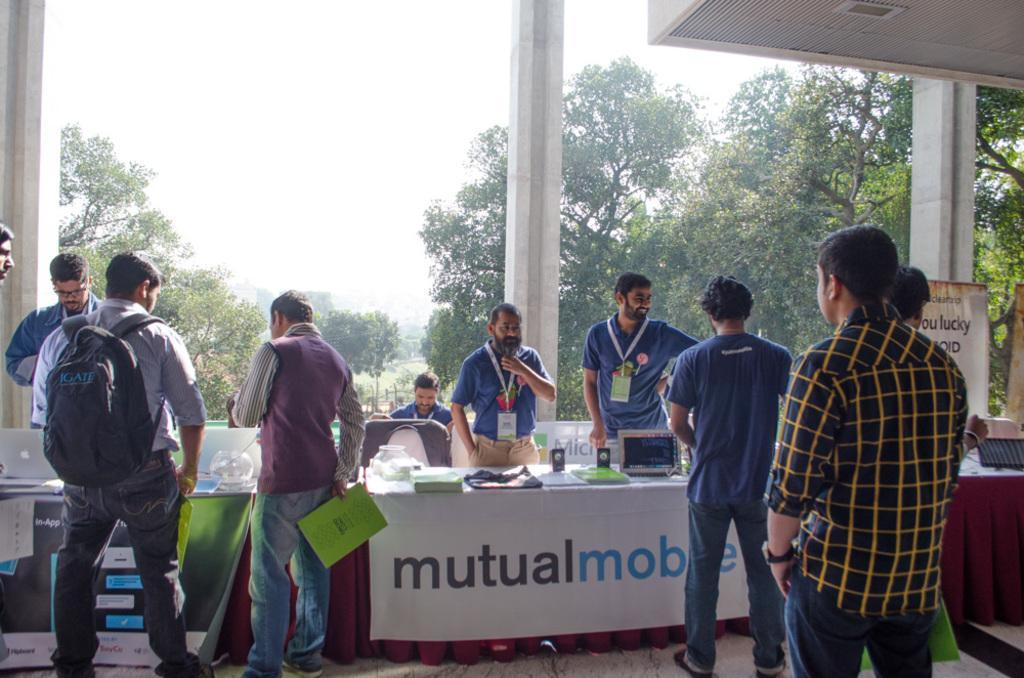Describe this image in one or two sentences. In this image we can see three pillars, two banners, two chairs, three tables covered with red cloth and white banners. So many objects are there on the table. There are 10 people, 9 persons standing and 1 man sitting. One person wearing bag and three people holding files. There are many trees outside of the building and at the top there is the sky. 